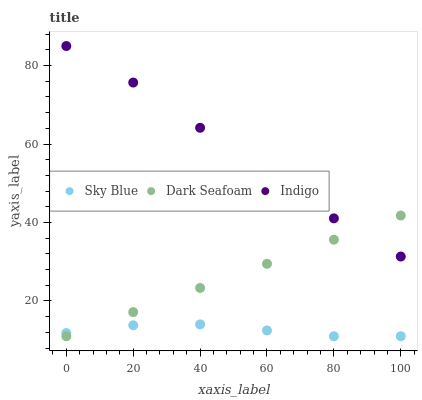Does Sky Blue have the minimum area under the curve?
Answer yes or no. Yes. Does Indigo have the maximum area under the curve?
Answer yes or no. Yes. Does Dark Seafoam have the minimum area under the curve?
Answer yes or no. No. Does Dark Seafoam have the maximum area under the curve?
Answer yes or no. No. Is Dark Seafoam the smoothest?
Answer yes or no. Yes. Is Indigo the roughest?
Answer yes or no. Yes. Is Indigo the smoothest?
Answer yes or no. No. Is Dark Seafoam the roughest?
Answer yes or no. No. Does Sky Blue have the lowest value?
Answer yes or no. Yes. Does Indigo have the lowest value?
Answer yes or no. No. Does Indigo have the highest value?
Answer yes or no. Yes. Does Dark Seafoam have the highest value?
Answer yes or no. No. Is Sky Blue less than Indigo?
Answer yes or no. Yes. Is Indigo greater than Sky Blue?
Answer yes or no. Yes. Does Indigo intersect Dark Seafoam?
Answer yes or no. Yes. Is Indigo less than Dark Seafoam?
Answer yes or no. No. Is Indigo greater than Dark Seafoam?
Answer yes or no. No. Does Sky Blue intersect Indigo?
Answer yes or no. No. 